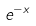Convert formula to latex. <formula><loc_0><loc_0><loc_500><loc_500>e ^ { - x }</formula> 